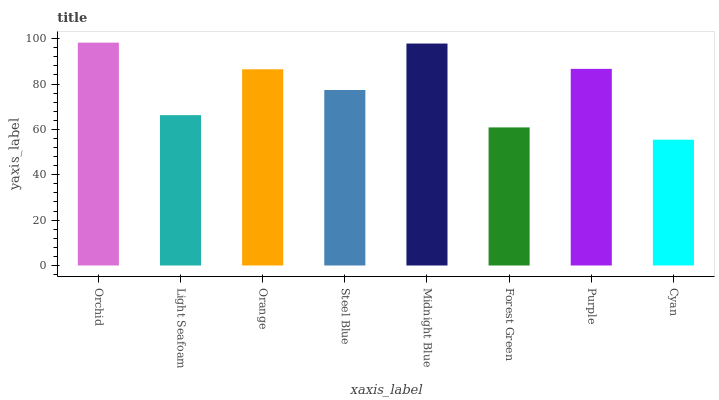Is Light Seafoam the minimum?
Answer yes or no. No. Is Light Seafoam the maximum?
Answer yes or no. No. Is Orchid greater than Light Seafoam?
Answer yes or no. Yes. Is Light Seafoam less than Orchid?
Answer yes or no. Yes. Is Light Seafoam greater than Orchid?
Answer yes or no. No. Is Orchid less than Light Seafoam?
Answer yes or no. No. Is Orange the high median?
Answer yes or no. Yes. Is Steel Blue the low median?
Answer yes or no. Yes. Is Purple the high median?
Answer yes or no. No. Is Midnight Blue the low median?
Answer yes or no. No. 